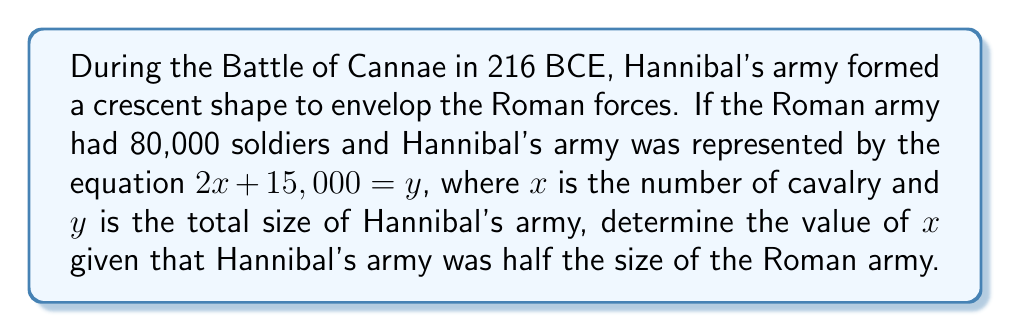Provide a solution to this math problem. Let's approach this step-by-step:

1) We know that the Roman army had 80,000 soldiers.

2) We're told that Hannibal's army was half the size of the Roman army. So:
   $$y = \frac{1}{2} \times 80,000 = 40,000$$

3) We're given the equation for Hannibal's army: $2x + 15,000 = y$
   Where $x$ is the number of cavalry and $y$ is the total size of Hannibal's army.

4) We can substitute our known value of $y$ into this equation:
   $$2x + 15,000 = 40,000$$

5) To solve for $x$, let's first subtract 15,000 from both sides:
   $$2x = 25,000$$

6) Now, divide both sides by 2:
   $$x = 12,500$$

Therefore, Hannibal had 12,500 cavalry in his army at the Battle of Cannae.
Answer: $x = 12,500$ 